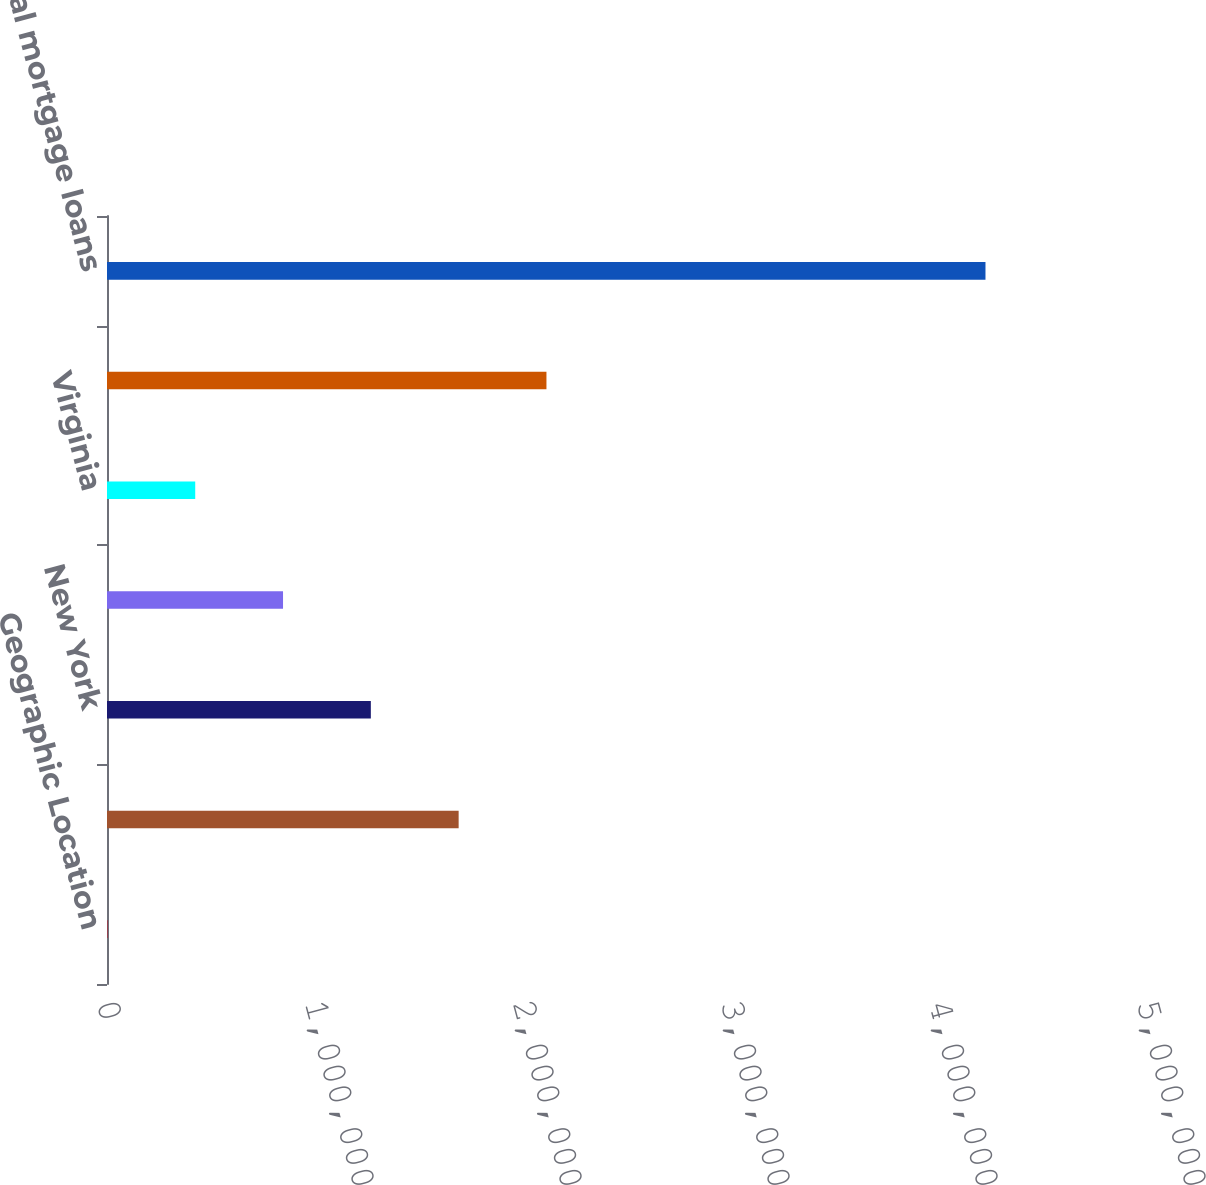Convert chart. <chart><loc_0><loc_0><loc_500><loc_500><bar_chart><fcel>Geographic Location<fcel>California<fcel>New York<fcel>Florida<fcel>Virginia<fcel>Other states<fcel>Total mortgage loans<nl><fcel>2012<fcel>1.69059e+06<fcel>1.26845e+06<fcel>846302<fcel>424157<fcel>2.11274e+06<fcel>4.22346e+06<nl></chart> 